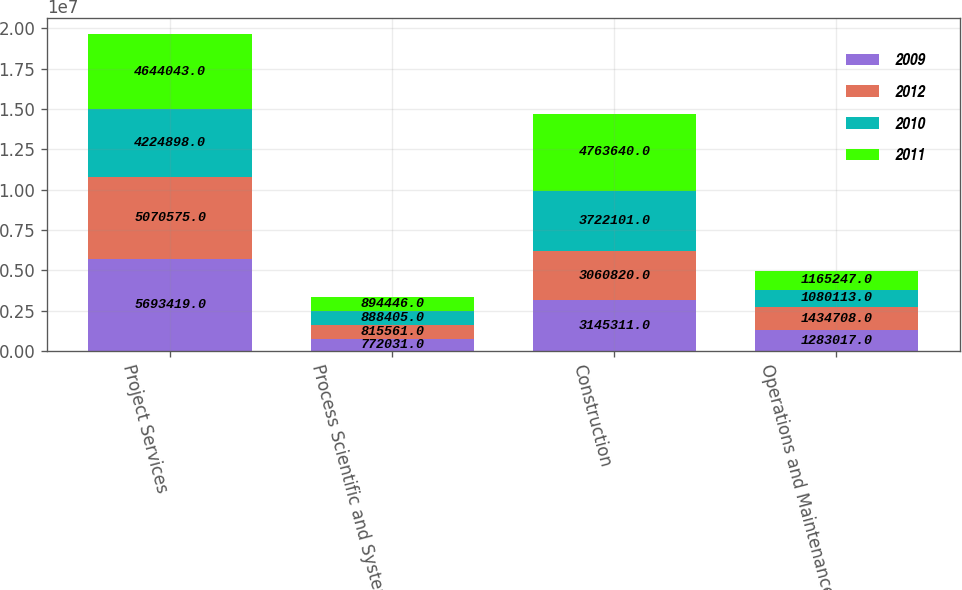<chart> <loc_0><loc_0><loc_500><loc_500><stacked_bar_chart><ecel><fcel>Project Services<fcel>Process Scientific and Systems<fcel>Construction<fcel>Operations and Maintenance<nl><fcel>2009<fcel>5.69342e+06<fcel>772031<fcel>3.14531e+06<fcel>1.28302e+06<nl><fcel>2012<fcel>5.07058e+06<fcel>815561<fcel>3.06082e+06<fcel>1.43471e+06<nl><fcel>2010<fcel>4.2249e+06<fcel>888405<fcel>3.7221e+06<fcel>1.08011e+06<nl><fcel>2011<fcel>4.64404e+06<fcel>894446<fcel>4.76364e+06<fcel>1.16525e+06<nl></chart> 